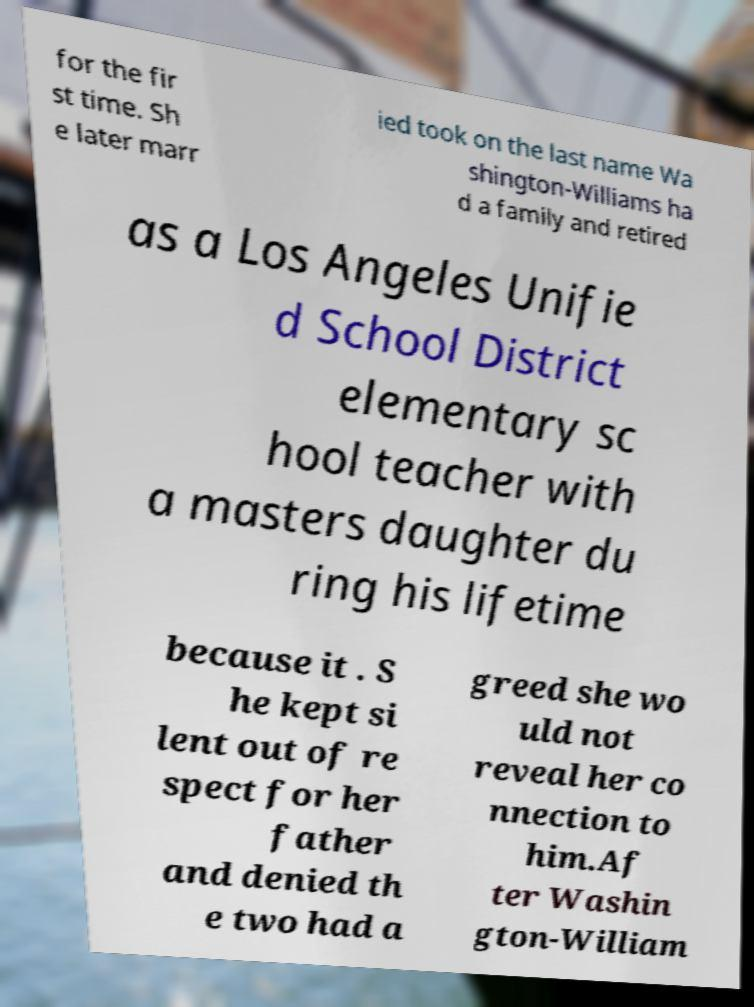There's text embedded in this image that I need extracted. Can you transcribe it verbatim? for the fir st time. Sh e later marr ied took on the last name Wa shington-Williams ha d a family and retired as a Los Angeles Unifie d School District elementary sc hool teacher with a masters daughter du ring his lifetime because it . S he kept si lent out of re spect for her father and denied th e two had a greed she wo uld not reveal her co nnection to him.Af ter Washin gton-William 